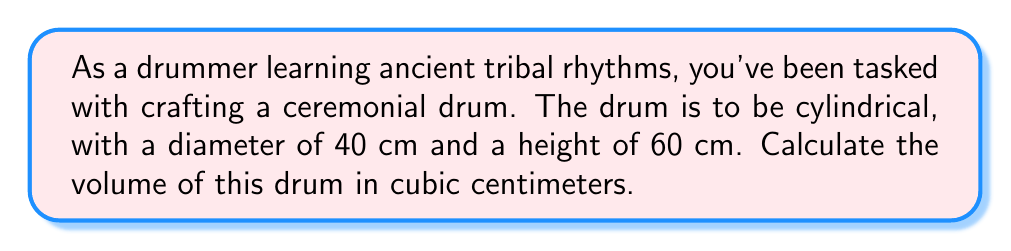Help me with this question. To calculate the volume of a cylindrical drum, we need to use the formula for the volume of a cylinder:

$$V = \pi r^2 h$$

Where:
$V$ = volume
$r$ = radius of the base
$h$ = height of the cylinder

Given:
- Diameter = 40 cm
- Height = 60 cm

Step 1: Calculate the radius
The radius is half the diameter:
$r = 40 \text{ cm} \div 2 = 20 \text{ cm}$

Step 2: Apply the volume formula
$$\begin{align}
V &= \pi r^2 h \\
&= \pi (20 \text{ cm})^2 (60 \text{ cm}) \\
&= \pi (400 \text{ cm}^2) (60 \text{ cm}) \\
&= 24000\pi \text{ cm}^3
\end{align}$$

Step 3: Calculate the final value
$V = 24000\pi \text{ cm}^3 \approx 75398.22 \text{ cm}^3$

[asy]
import three;

size(200);
currentprojection=perspective(6,3,2);

draw(cylinder((0,0,0),20,60),opacity(0.5));
draw(circle((0,0,0),20),dashed);
draw(circle((0,0,60),20));

label("60 cm",(25,0,30),E);
label("40 cm",(0,-20,0),S);
[/asy]
Answer: $75398.22 \text{ cm}^3$ 